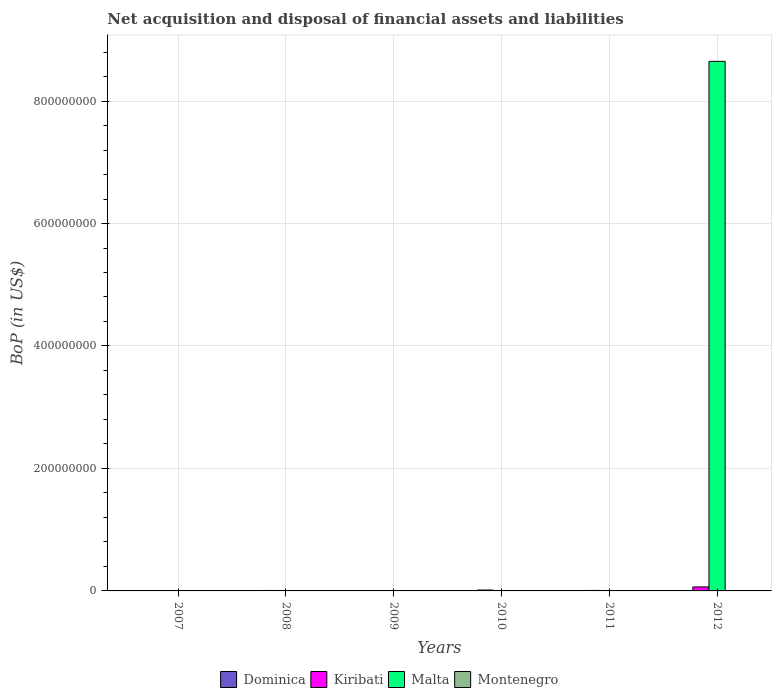Are the number of bars on each tick of the X-axis equal?
Keep it short and to the point. No. How many bars are there on the 1st tick from the left?
Give a very brief answer. 0. What is the label of the 1st group of bars from the left?
Make the answer very short. 2007. In how many cases, is the number of bars for a given year not equal to the number of legend labels?
Your answer should be very brief. 6. What is the Balance of Payments in Malta in 2008?
Keep it short and to the point. 0. Across all years, what is the maximum Balance of Payments in Kiribati?
Make the answer very short. 6.49e+06. What is the total Balance of Payments in Montenegro in the graph?
Make the answer very short. 0. What is the difference between the Balance of Payments in Kiribati in 2010 and that in 2012?
Provide a short and direct response. -5.03e+06. What is the difference between the Balance of Payments in Montenegro in 2008 and the Balance of Payments in Malta in 2010?
Give a very brief answer. 0. In how many years, is the Balance of Payments in Montenegro greater than 200000000 US$?
Your answer should be very brief. 0. What is the ratio of the Balance of Payments in Kiribati in 2010 to that in 2012?
Keep it short and to the point. 0.22. Is the Balance of Payments in Kiribati in 2010 less than that in 2011?
Your response must be concise. No. What is the difference between the highest and the lowest Balance of Payments in Malta?
Keep it short and to the point. 8.65e+08. Is the sum of the Balance of Payments in Kiribati in 2008 and 2011 greater than the maximum Balance of Payments in Dominica across all years?
Provide a succinct answer. Yes. Are all the bars in the graph horizontal?
Give a very brief answer. No. What is the difference between two consecutive major ticks on the Y-axis?
Provide a succinct answer. 2.00e+08. Are the values on the major ticks of Y-axis written in scientific E-notation?
Ensure brevity in your answer.  No. Where does the legend appear in the graph?
Give a very brief answer. Bottom center. How are the legend labels stacked?
Provide a short and direct response. Horizontal. What is the title of the graph?
Ensure brevity in your answer.  Net acquisition and disposal of financial assets and liabilities. What is the label or title of the X-axis?
Your answer should be very brief. Years. What is the label or title of the Y-axis?
Keep it short and to the point. BoP (in US$). What is the BoP (in US$) in Dominica in 2007?
Provide a short and direct response. 0. What is the BoP (in US$) in Kiribati in 2007?
Your answer should be compact. 0. What is the BoP (in US$) in Montenegro in 2007?
Your answer should be compact. 0. What is the BoP (in US$) of Dominica in 2008?
Keep it short and to the point. 0. What is the BoP (in US$) of Kiribati in 2008?
Your response must be concise. 7.43e+05. What is the BoP (in US$) in Malta in 2008?
Your answer should be very brief. 0. What is the BoP (in US$) in Montenegro in 2008?
Ensure brevity in your answer.  0. What is the BoP (in US$) of Kiribati in 2010?
Provide a short and direct response. 1.46e+06. What is the BoP (in US$) of Malta in 2010?
Provide a succinct answer. 0. What is the BoP (in US$) of Montenegro in 2010?
Provide a short and direct response. 0. What is the BoP (in US$) of Kiribati in 2011?
Your response must be concise. 8.14e+05. What is the BoP (in US$) in Malta in 2011?
Your answer should be very brief. 0. What is the BoP (in US$) in Dominica in 2012?
Your answer should be compact. 0. What is the BoP (in US$) in Kiribati in 2012?
Your answer should be very brief. 6.49e+06. What is the BoP (in US$) in Malta in 2012?
Your answer should be very brief. 8.65e+08. Across all years, what is the maximum BoP (in US$) of Kiribati?
Provide a short and direct response. 6.49e+06. Across all years, what is the maximum BoP (in US$) in Malta?
Offer a very short reply. 8.65e+08. What is the total BoP (in US$) in Dominica in the graph?
Offer a very short reply. 0. What is the total BoP (in US$) in Kiribati in the graph?
Ensure brevity in your answer.  9.50e+06. What is the total BoP (in US$) in Malta in the graph?
Keep it short and to the point. 8.65e+08. What is the total BoP (in US$) of Montenegro in the graph?
Provide a succinct answer. 0. What is the difference between the BoP (in US$) in Kiribati in 2008 and that in 2010?
Offer a terse response. -7.16e+05. What is the difference between the BoP (in US$) of Kiribati in 2008 and that in 2011?
Give a very brief answer. -7.17e+04. What is the difference between the BoP (in US$) of Kiribati in 2008 and that in 2012?
Provide a succinct answer. -5.75e+06. What is the difference between the BoP (in US$) of Kiribati in 2010 and that in 2011?
Give a very brief answer. 6.44e+05. What is the difference between the BoP (in US$) of Kiribati in 2010 and that in 2012?
Offer a very short reply. -5.03e+06. What is the difference between the BoP (in US$) in Kiribati in 2011 and that in 2012?
Your response must be concise. -5.67e+06. What is the difference between the BoP (in US$) in Kiribati in 2008 and the BoP (in US$) in Malta in 2012?
Make the answer very short. -8.64e+08. What is the difference between the BoP (in US$) in Kiribati in 2010 and the BoP (in US$) in Malta in 2012?
Provide a succinct answer. -8.63e+08. What is the difference between the BoP (in US$) of Kiribati in 2011 and the BoP (in US$) of Malta in 2012?
Provide a short and direct response. -8.64e+08. What is the average BoP (in US$) in Dominica per year?
Your answer should be compact. 0. What is the average BoP (in US$) in Kiribati per year?
Make the answer very short. 1.58e+06. What is the average BoP (in US$) in Malta per year?
Provide a short and direct response. 1.44e+08. What is the average BoP (in US$) of Montenegro per year?
Offer a terse response. 0. In the year 2012, what is the difference between the BoP (in US$) in Kiribati and BoP (in US$) in Malta?
Keep it short and to the point. -8.58e+08. What is the ratio of the BoP (in US$) in Kiribati in 2008 to that in 2010?
Your answer should be very brief. 0.51. What is the ratio of the BoP (in US$) of Kiribati in 2008 to that in 2011?
Give a very brief answer. 0.91. What is the ratio of the BoP (in US$) in Kiribati in 2008 to that in 2012?
Your response must be concise. 0.11. What is the ratio of the BoP (in US$) of Kiribati in 2010 to that in 2011?
Your answer should be compact. 1.79. What is the ratio of the BoP (in US$) in Kiribati in 2010 to that in 2012?
Your answer should be compact. 0.22. What is the ratio of the BoP (in US$) of Kiribati in 2011 to that in 2012?
Offer a very short reply. 0.13. What is the difference between the highest and the second highest BoP (in US$) in Kiribati?
Make the answer very short. 5.03e+06. What is the difference between the highest and the lowest BoP (in US$) of Kiribati?
Your answer should be very brief. 6.49e+06. What is the difference between the highest and the lowest BoP (in US$) of Malta?
Keep it short and to the point. 8.65e+08. 